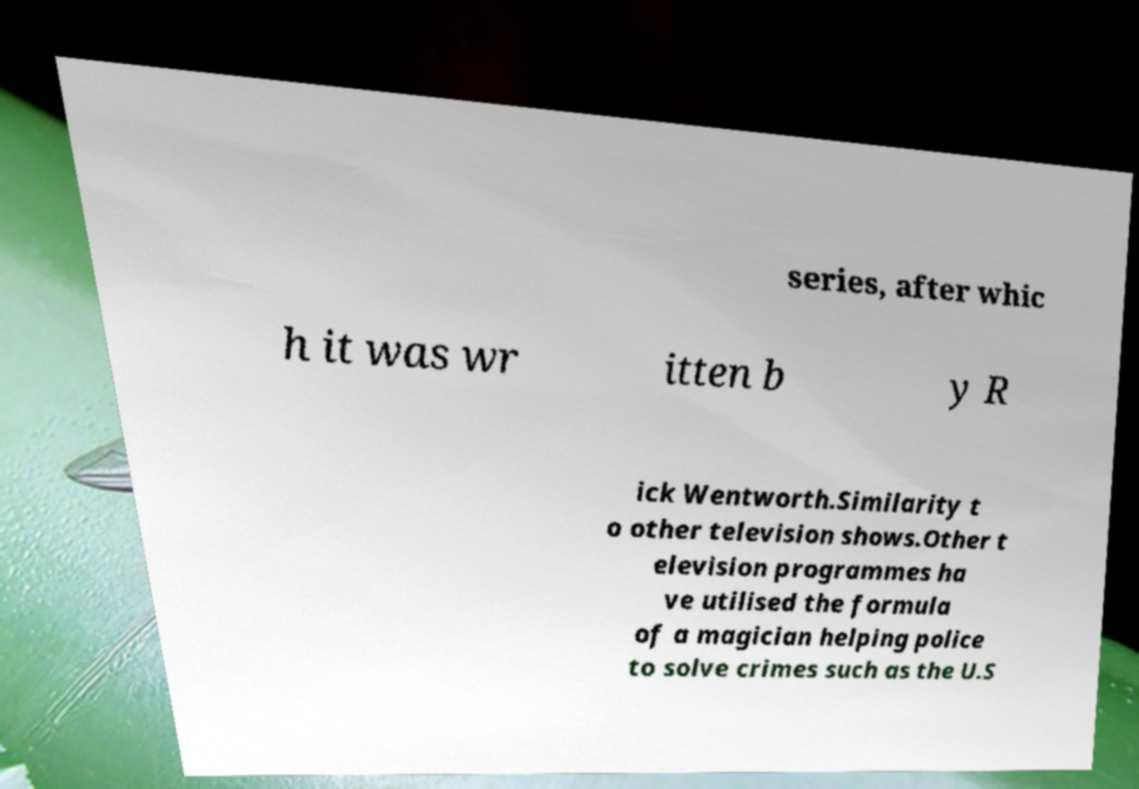Can you read and provide the text displayed in the image?This photo seems to have some interesting text. Can you extract and type it out for me? series, after whic h it was wr itten b y R ick Wentworth.Similarity t o other television shows.Other t elevision programmes ha ve utilised the formula of a magician helping police to solve crimes such as the U.S 